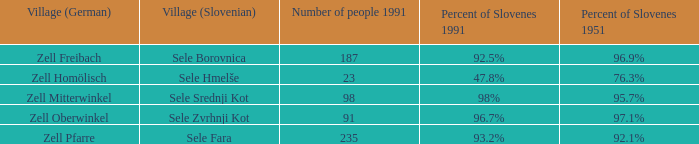Provide me with the name of the village (German) where there is 96.9% Slovenes in 1951.  Zell Freibach. 